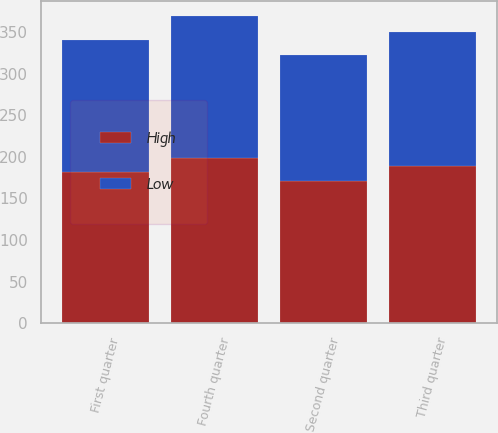Convert chart to OTSL. <chart><loc_0><loc_0><loc_500><loc_500><stacked_bar_chart><ecel><fcel>First quarter<fcel>Second quarter<fcel>Third quarter<fcel>Fourth quarter<nl><fcel>High<fcel>181.13<fcel>171.08<fcel>188.58<fcel>198.06<nl><fcel>Low<fcel>159.77<fcel>151.65<fcel>161.53<fcel>171.26<nl></chart> 